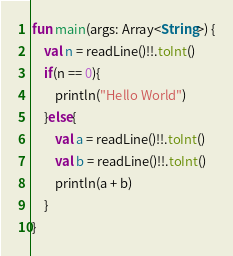<code> <loc_0><loc_0><loc_500><loc_500><_Kotlin_>fun main(args: Array<String>) {
    val n = readLine()!!.toInt()
    if(n == 0){
        println("Hello World")
    }else{
        val a = readLine()!!.toInt()
        val b = readLine()!!.toInt()
        println(a + b)
    }
}</code> 